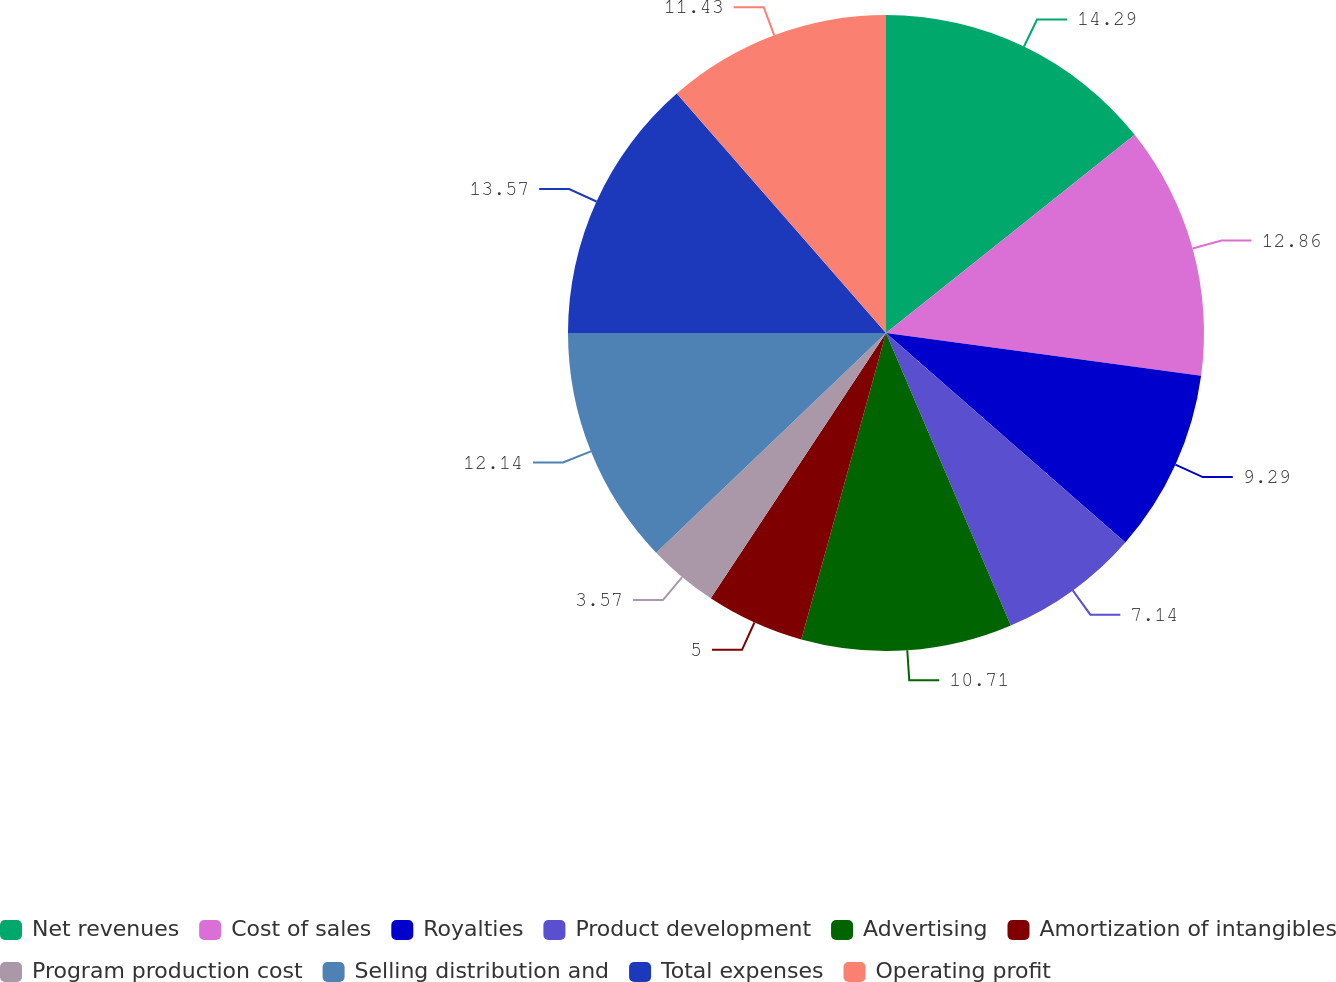<chart> <loc_0><loc_0><loc_500><loc_500><pie_chart><fcel>Net revenues<fcel>Cost of sales<fcel>Royalties<fcel>Product development<fcel>Advertising<fcel>Amortization of intangibles<fcel>Program production cost<fcel>Selling distribution and<fcel>Total expenses<fcel>Operating profit<nl><fcel>14.29%<fcel>12.86%<fcel>9.29%<fcel>7.14%<fcel>10.71%<fcel>5.0%<fcel>3.57%<fcel>12.14%<fcel>13.57%<fcel>11.43%<nl></chart> 